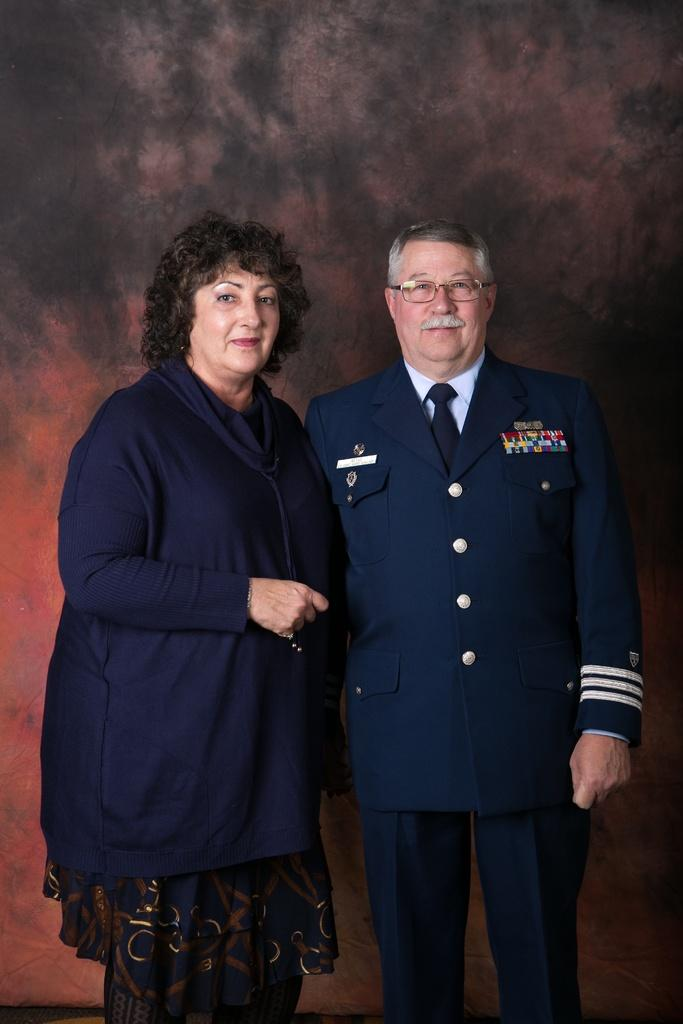How many people are in the image? There are two persons standing in the image. What can be seen in the background of the image? The background of the image is black. Where is the mailbox located in the image? There is no mailbox present in the image. What type of tent can be seen in the image? There is no tent present in the image. 